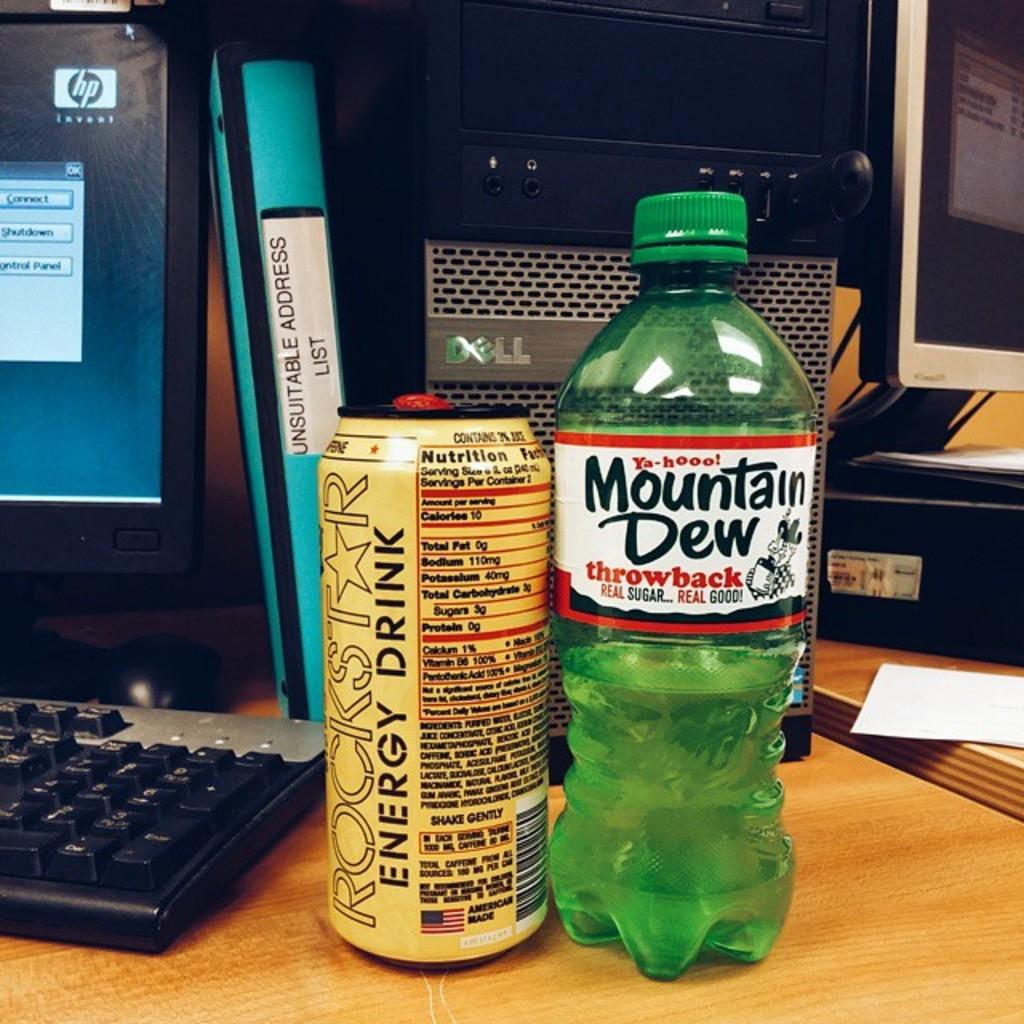What type of beverage container is visible in the image? There is a water bottle in the image. What other type of beverage container can be seen in the image? There is an energy drink can in the image. What is the primary object used for typing in the image? There is a keyboard in the image. What is the primary object used for displaying visual information in the image? There is a monitor in the image. What type of items can be seen on the table in the image? There are books on the table in the image. What type of church can be seen in the image? There is no church present in the image. What type of oil is visible in the image? There is no oil present in the image. 